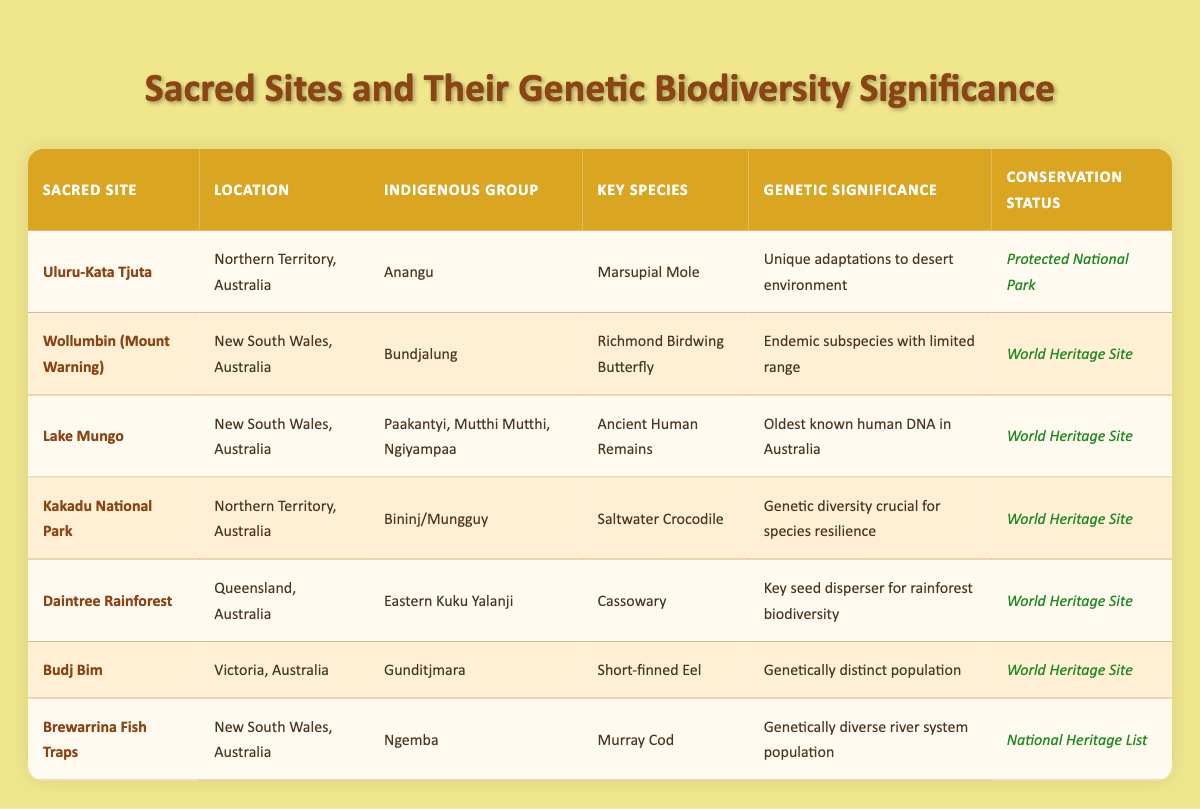What species is found at Uluru-Kata Tjuta? The table indicates that the key species at Uluru-Kata Tjuta is the Marsupial Mole.
Answer: Marsupial Mole Which sacred site is associated with the Bundjalung Indigenous group? According to the table, the Wollumbin (Mount Warning) sacred site is associated with the Bundjalung Indigenous group.
Answer: Wollumbin (Mount Warning) Is the Daintree Rainforest a protected area? The table lists the Daintree Rainforest as a World Heritage Site, which indicates that it is protected.
Answer: Yes Which sacred site has the oldest known human DNA in Australia? The data in the table shows that Lake Mungo has the oldest known human DNA in Australia, evidenced by ancient human remains found there.
Answer: Lake Mungo How many sacred sites are listed as World Heritage Sites? There are five sacred sites labeled as World Heritage Sites: Wollumbin, Lake Mungo, Kakadu National Park, Daintree Rainforest, and Budj Bim. Counting these gives a total of 5.
Answer: 5 What conservation status is assigned to the Brewarrina Fish Traps? The table states that the Brewarrina Fish Traps have a conservation status listed under the National Heritage List.
Answer: National Heritage List Which sacred site features the Saltwater Crocodile as a key species? The Saltwater Crocodile is identified as a key species at the Kakadu National Park, as noted in the table.
Answer: Kakadu National Park What is the genetic significance of the Richmond Birdwing Butterfly? The table states that the genetic significance of the Richmond Birdwing Butterfly is its status as an endemic subspecies with a limited range. Thus, its genetic makeup is significant for conservation.
Answer: Endemic subspecies with limited range What key species is noted for being a vital seed disperser in the Daintree Rainforest? The table presents the Cassowary as the key species noted for being a vital seed disperser in the Daintree Rainforest, which is significant for maintaining biodiversity.
Answer: Cassowary 